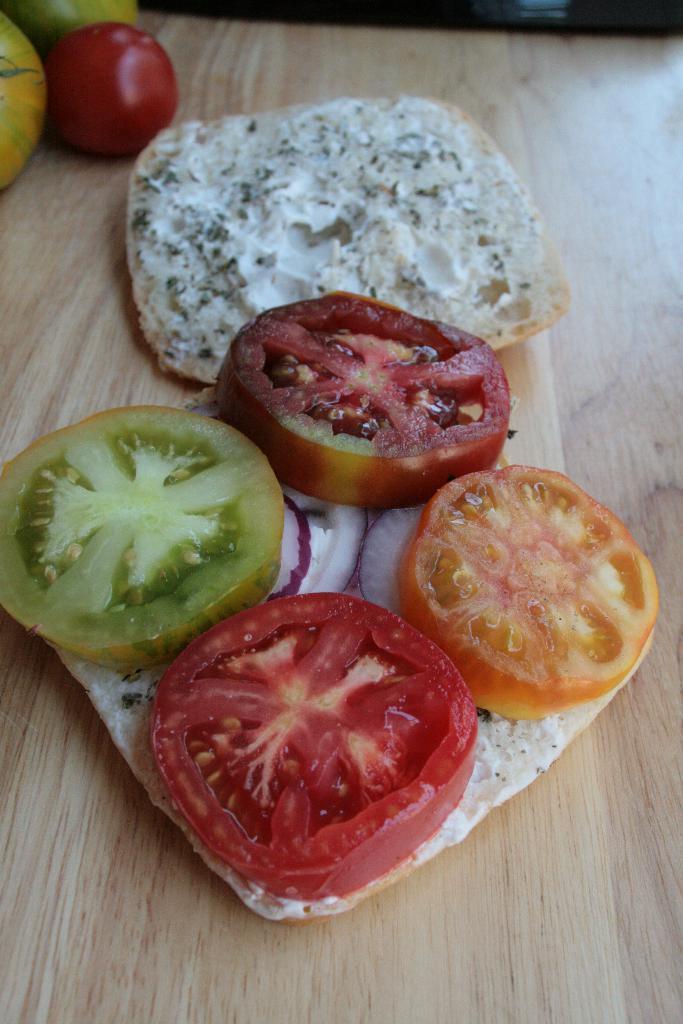In one or two sentences, can you explain what this image depicts? This is a zoomed in picture. In the center we can see a food item seems to be a sandwich places on the top of the table. In the background we can see a tomato and some other vegetables are placed on the top of the wooden table. 